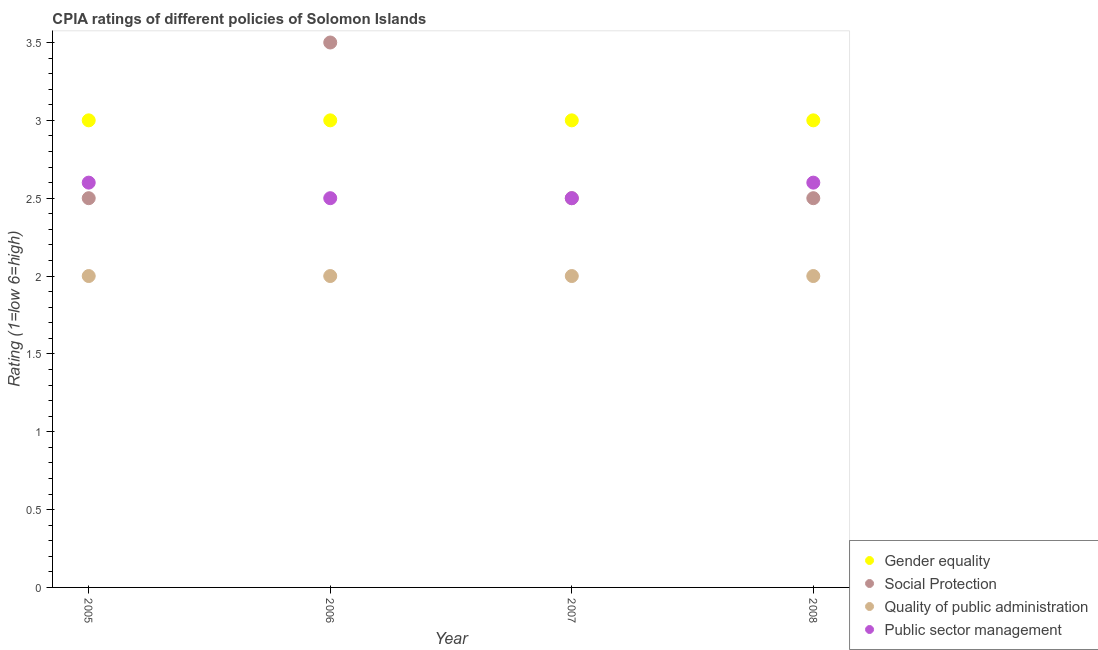How many different coloured dotlines are there?
Offer a very short reply. 4. Across all years, what is the maximum cpia rating of quality of public administration?
Offer a terse response. 2. Across all years, what is the minimum cpia rating of gender equality?
Ensure brevity in your answer.  3. In which year was the cpia rating of quality of public administration maximum?
Give a very brief answer. 2005. In which year was the cpia rating of public sector management minimum?
Provide a succinct answer. 2006. What is the total cpia rating of gender equality in the graph?
Ensure brevity in your answer.  12. What is the average cpia rating of public sector management per year?
Ensure brevity in your answer.  2.55. In the year 2006, what is the difference between the cpia rating of gender equality and cpia rating of social protection?
Your response must be concise. -0.5. In how many years, is the cpia rating of public sector management greater than 0.1?
Give a very brief answer. 4. What is the ratio of the cpia rating of quality of public administration in 2006 to that in 2008?
Keep it short and to the point. 1. Is the difference between the cpia rating of quality of public administration in 2005 and 2008 greater than the difference between the cpia rating of gender equality in 2005 and 2008?
Ensure brevity in your answer.  No. In how many years, is the cpia rating of quality of public administration greater than the average cpia rating of quality of public administration taken over all years?
Your response must be concise. 0. Is the sum of the cpia rating of gender equality in 2006 and 2007 greater than the maximum cpia rating of social protection across all years?
Ensure brevity in your answer.  Yes. Is the cpia rating of quality of public administration strictly greater than the cpia rating of social protection over the years?
Give a very brief answer. No. Is the cpia rating of gender equality strictly less than the cpia rating of quality of public administration over the years?
Make the answer very short. No. How many dotlines are there?
Offer a terse response. 4. Are the values on the major ticks of Y-axis written in scientific E-notation?
Your response must be concise. No. Does the graph contain grids?
Provide a short and direct response. No. Where does the legend appear in the graph?
Your answer should be compact. Bottom right. How are the legend labels stacked?
Your answer should be very brief. Vertical. What is the title of the graph?
Keep it short and to the point. CPIA ratings of different policies of Solomon Islands. Does "Mammal species" appear as one of the legend labels in the graph?
Provide a short and direct response. No. What is the Rating (1=low 6=high) of Quality of public administration in 2005?
Ensure brevity in your answer.  2. What is the Rating (1=low 6=high) of Public sector management in 2005?
Your answer should be compact. 2.6. What is the Rating (1=low 6=high) of Gender equality in 2006?
Give a very brief answer. 3. What is the Rating (1=low 6=high) in Quality of public administration in 2006?
Your answer should be very brief. 2. What is the Rating (1=low 6=high) in Gender equality in 2007?
Offer a terse response. 3. What is the Rating (1=low 6=high) of Social Protection in 2007?
Your answer should be compact. 2.5. What is the Rating (1=low 6=high) of Social Protection in 2008?
Offer a very short reply. 2.5. Across all years, what is the maximum Rating (1=low 6=high) of Gender equality?
Your answer should be compact. 3. Across all years, what is the minimum Rating (1=low 6=high) of Social Protection?
Provide a succinct answer. 2.5. What is the total Rating (1=low 6=high) in Gender equality in the graph?
Provide a succinct answer. 12. What is the total Rating (1=low 6=high) of Social Protection in the graph?
Keep it short and to the point. 11. What is the total Rating (1=low 6=high) in Quality of public administration in the graph?
Make the answer very short. 8. What is the total Rating (1=low 6=high) of Public sector management in the graph?
Provide a short and direct response. 10.2. What is the difference between the Rating (1=low 6=high) in Gender equality in 2005 and that in 2006?
Provide a succinct answer. 0. What is the difference between the Rating (1=low 6=high) of Quality of public administration in 2005 and that in 2006?
Offer a terse response. 0. What is the difference between the Rating (1=low 6=high) in Social Protection in 2005 and that in 2007?
Make the answer very short. 0. What is the difference between the Rating (1=low 6=high) in Quality of public administration in 2005 and that in 2008?
Make the answer very short. 0. What is the difference between the Rating (1=low 6=high) in Public sector management in 2005 and that in 2008?
Keep it short and to the point. 0. What is the difference between the Rating (1=low 6=high) in Quality of public administration in 2006 and that in 2007?
Make the answer very short. 0. What is the difference between the Rating (1=low 6=high) in Public sector management in 2006 and that in 2007?
Provide a short and direct response. 0. What is the difference between the Rating (1=low 6=high) in Social Protection in 2006 and that in 2008?
Your answer should be very brief. 1. What is the difference between the Rating (1=low 6=high) of Quality of public administration in 2006 and that in 2008?
Your answer should be compact. 0. What is the difference between the Rating (1=low 6=high) in Public sector management in 2006 and that in 2008?
Your answer should be very brief. -0.1. What is the difference between the Rating (1=low 6=high) in Social Protection in 2007 and that in 2008?
Your answer should be compact. 0. What is the difference between the Rating (1=low 6=high) of Public sector management in 2007 and that in 2008?
Give a very brief answer. -0.1. What is the difference between the Rating (1=low 6=high) in Gender equality in 2005 and the Rating (1=low 6=high) in Quality of public administration in 2006?
Offer a terse response. 1. What is the difference between the Rating (1=low 6=high) of Gender equality in 2005 and the Rating (1=low 6=high) of Public sector management in 2006?
Give a very brief answer. 0.5. What is the difference between the Rating (1=low 6=high) in Social Protection in 2005 and the Rating (1=low 6=high) in Quality of public administration in 2006?
Your answer should be very brief. 0.5. What is the difference between the Rating (1=low 6=high) of Gender equality in 2005 and the Rating (1=low 6=high) of Quality of public administration in 2007?
Ensure brevity in your answer.  1. What is the difference between the Rating (1=low 6=high) in Quality of public administration in 2005 and the Rating (1=low 6=high) in Public sector management in 2007?
Provide a succinct answer. -0.5. What is the difference between the Rating (1=low 6=high) of Gender equality in 2005 and the Rating (1=low 6=high) of Public sector management in 2008?
Ensure brevity in your answer.  0.4. What is the difference between the Rating (1=low 6=high) of Social Protection in 2005 and the Rating (1=low 6=high) of Quality of public administration in 2008?
Your response must be concise. 0.5. What is the difference between the Rating (1=low 6=high) in Social Protection in 2005 and the Rating (1=low 6=high) in Public sector management in 2008?
Offer a terse response. -0.1. What is the difference between the Rating (1=low 6=high) of Gender equality in 2006 and the Rating (1=low 6=high) of Social Protection in 2007?
Offer a very short reply. 0.5. What is the difference between the Rating (1=low 6=high) in Social Protection in 2006 and the Rating (1=low 6=high) in Quality of public administration in 2007?
Give a very brief answer. 1.5. What is the difference between the Rating (1=low 6=high) in Gender equality in 2006 and the Rating (1=low 6=high) in Public sector management in 2008?
Provide a short and direct response. 0.4. What is the difference between the Rating (1=low 6=high) in Social Protection in 2006 and the Rating (1=low 6=high) in Quality of public administration in 2008?
Offer a terse response. 1.5. What is the difference between the Rating (1=low 6=high) in Quality of public administration in 2006 and the Rating (1=low 6=high) in Public sector management in 2008?
Keep it short and to the point. -0.6. What is the difference between the Rating (1=low 6=high) of Gender equality in 2007 and the Rating (1=low 6=high) of Social Protection in 2008?
Offer a terse response. 0.5. What is the difference between the Rating (1=low 6=high) of Gender equality in 2007 and the Rating (1=low 6=high) of Quality of public administration in 2008?
Give a very brief answer. 1. What is the difference between the Rating (1=low 6=high) in Social Protection in 2007 and the Rating (1=low 6=high) in Quality of public administration in 2008?
Provide a short and direct response. 0.5. What is the difference between the Rating (1=low 6=high) in Social Protection in 2007 and the Rating (1=low 6=high) in Public sector management in 2008?
Offer a terse response. -0.1. What is the difference between the Rating (1=low 6=high) of Quality of public administration in 2007 and the Rating (1=low 6=high) of Public sector management in 2008?
Your response must be concise. -0.6. What is the average Rating (1=low 6=high) of Gender equality per year?
Offer a very short reply. 3. What is the average Rating (1=low 6=high) of Social Protection per year?
Provide a succinct answer. 2.75. What is the average Rating (1=low 6=high) in Public sector management per year?
Ensure brevity in your answer.  2.55. In the year 2005, what is the difference between the Rating (1=low 6=high) in Social Protection and Rating (1=low 6=high) in Public sector management?
Offer a terse response. -0.1. In the year 2005, what is the difference between the Rating (1=low 6=high) of Quality of public administration and Rating (1=low 6=high) of Public sector management?
Your answer should be compact. -0.6. In the year 2006, what is the difference between the Rating (1=low 6=high) of Gender equality and Rating (1=low 6=high) of Social Protection?
Provide a succinct answer. -0.5. In the year 2006, what is the difference between the Rating (1=low 6=high) of Gender equality and Rating (1=low 6=high) of Public sector management?
Make the answer very short. 0.5. In the year 2006, what is the difference between the Rating (1=low 6=high) in Social Protection and Rating (1=low 6=high) in Quality of public administration?
Ensure brevity in your answer.  1.5. In the year 2006, what is the difference between the Rating (1=low 6=high) in Quality of public administration and Rating (1=low 6=high) in Public sector management?
Your answer should be very brief. -0.5. In the year 2007, what is the difference between the Rating (1=low 6=high) in Gender equality and Rating (1=low 6=high) in Public sector management?
Your answer should be compact. 0.5. In the year 2007, what is the difference between the Rating (1=low 6=high) in Social Protection and Rating (1=low 6=high) in Quality of public administration?
Offer a very short reply. 0.5. In the year 2007, what is the difference between the Rating (1=low 6=high) of Social Protection and Rating (1=low 6=high) of Public sector management?
Your response must be concise. 0. In the year 2008, what is the difference between the Rating (1=low 6=high) of Gender equality and Rating (1=low 6=high) of Social Protection?
Your answer should be compact. 0.5. In the year 2008, what is the difference between the Rating (1=low 6=high) of Gender equality and Rating (1=low 6=high) of Quality of public administration?
Offer a terse response. 1. In the year 2008, what is the difference between the Rating (1=low 6=high) of Social Protection and Rating (1=low 6=high) of Quality of public administration?
Your response must be concise. 0.5. In the year 2008, what is the difference between the Rating (1=low 6=high) in Social Protection and Rating (1=low 6=high) in Public sector management?
Your response must be concise. -0.1. In the year 2008, what is the difference between the Rating (1=low 6=high) of Quality of public administration and Rating (1=low 6=high) of Public sector management?
Provide a short and direct response. -0.6. What is the ratio of the Rating (1=low 6=high) in Social Protection in 2005 to that in 2006?
Your response must be concise. 0.71. What is the ratio of the Rating (1=low 6=high) of Quality of public administration in 2005 to that in 2006?
Your answer should be very brief. 1. What is the ratio of the Rating (1=low 6=high) in Public sector management in 2005 to that in 2006?
Your answer should be compact. 1.04. What is the ratio of the Rating (1=low 6=high) in Gender equality in 2005 to that in 2007?
Your answer should be very brief. 1. What is the ratio of the Rating (1=low 6=high) of Public sector management in 2005 to that in 2007?
Provide a short and direct response. 1.04. What is the ratio of the Rating (1=low 6=high) in Gender equality in 2005 to that in 2008?
Ensure brevity in your answer.  1. What is the ratio of the Rating (1=low 6=high) in Social Protection in 2005 to that in 2008?
Your response must be concise. 1. What is the ratio of the Rating (1=low 6=high) in Public sector management in 2005 to that in 2008?
Your answer should be very brief. 1. What is the ratio of the Rating (1=low 6=high) in Public sector management in 2006 to that in 2007?
Your answer should be compact. 1. What is the ratio of the Rating (1=low 6=high) of Gender equality in 2006 to that in 2008?
Provide a succinct answer. 1. What is the ratio of the Rating (1=low 6=high) of Quality of public administration in 2006 to that in 2008?
Ensure brevity in your answer.  1. What is the ratio of the Rating (1=low 6=high) of Public sector management in 2006 to that in 2008?
Ensure brevity in your answer.  0.96. What is the ratio of the Rating (1=low 6=high) of Social Protection in 2007 to that in 2008?
Provide a short and direct response. 1. What is the ratio of the Rating (1=low 6=high) in Quality of public administration in 2007 to that in 2008?
Make the answer very short. 1. What is the ratio of the Rating (1=low 6=high) of Public sector management in 2007 to that in 2008?
Keep it short and to the point. 0.96. What is the difference between the highest and the second highest Rating (1=low 6=high) in Gender equality?
Provide a succinct answer. 0. What is the difference between the highest and the second highest Rating (1=low 6=high) in Social Protection?
Your response must be concise. 1. What is the difference between the highest and the second highest Rating (1=low 6=high) of Quality of public administration?
Provide a short and direct response. 0. What is the difference between the highest and the second highest Rating (1=low 6=high) in Public sector management?
Keep it short and to the point. 0. What is the difference between the highest and the lowest Rating (1=low 6=high) of Gender equality?
Provide a short and direct response. 0. What is the difference between the highest and the lowest Rating (1=low 6=high) in Quality of public administration?
Provide a short and direct response. 0. What is the difference between the highest and the lowest Rating (1=low 6=high) of Public sector management?
Give a very brief answer. 0.1. 